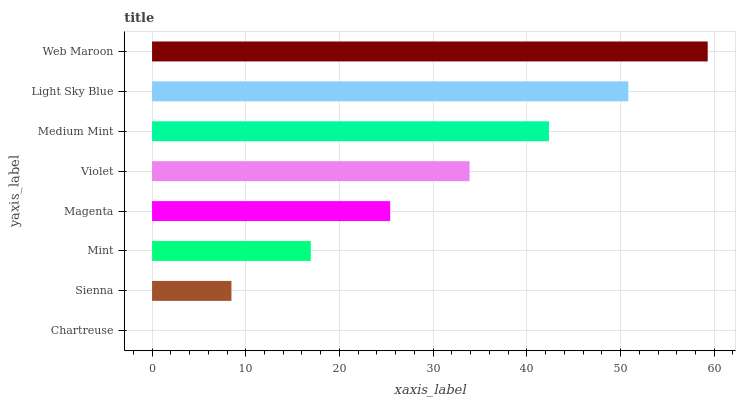Is Chartreuse the minimum?
Answer yes or no. Yes. Is Web Maroon the maximum?
Answer yes or no. Yes. Is Sienna the minimum?
Answer yes or no. No. Is Sienna the maximum?
Answer yes or no. No. Is Sienna greater than Chartreuse?
Answer yes or no. Yes. Is Chartreuse less than Sienna?
Answer yes or no. Yes. Is Chartreuse greater than Sienna?
Answer yes or no. No. Is Sienna less than Chartreuse?
Answer yes or no. No. Is Violet the high median?
Answer yes or no. Yes. Is Magenta the low median?
Answer yes or no. Yes. Is Sienna the high median?
Answer yes or no. No. Is Violet the low median?
Answer yes or no. No. 